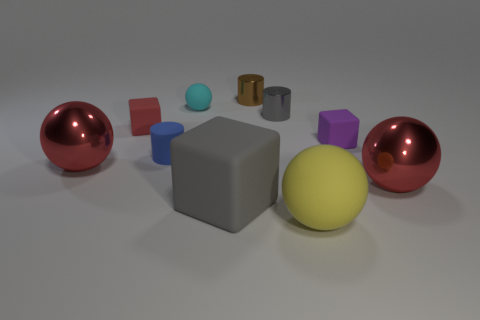Subtract all small cyan matte balls. How many balls are left? 3 Subtract all purple blocks. How many blocks are left? 2 Subtract 2 cylinders. How many cylinders are left? 1 Subtract all blocks. How many objects are left? 7 Subtract all cyan spheres. How many red cylinders are left? 0 Subtract 1 gray blocks. How many objects are left? 9 Subtract all red balls. Subtract all red cylinders. How many balls are left? 2 Subtract all big red spheres. Subtract all metal cylinders. How many objects are left? 6 Add 5 large matte balls. How many large matte balls are left? 6 Add 9 big blue matte objects. How many big blue matte objects exist? 9 